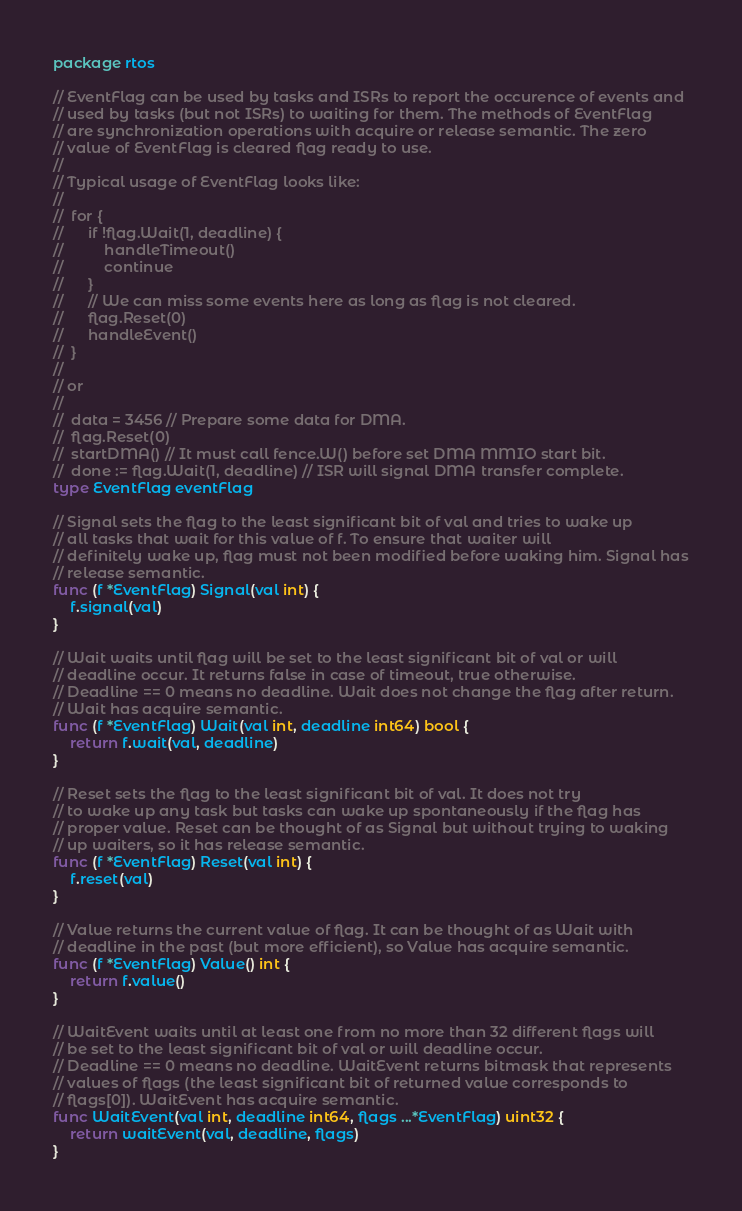<code> <loc_0><loc_0><loc_500><loc_500><_Go_>package rtos

// EventFlag can be used by tasks and ISRs to report the occurence of events and
// used by tasks (but not ISRs) to waiting for them. The methods of EventFlag
// are synchronization operations with acquire or release semantic. The zero
// value of EventFlag is cleared flag ready to use.
//
// Typical usage of EventFlag looks like:
//
//	for {
//		if !flag.Wait(1, deadline) {
//			handleTimeout()
//			continue
//		}
//		// We can miss some events here as long as flag is not cleared.
//		flag.Reset(0)
//		handleEvent()
//	}
//
// or
//
//	data = 3456 // Prepare some data for DMA.
//	flag.Reset(0)
//	startDMA() // It must call fence.W() before set DMA MMIO start bit.
//	done := flag.Wait(1, deadline) // ISR will signal DMA transfer complete.
type EventFlag eventFlag

// Signal sets the flag to the least significant bit of val and tries to wake up
// all tasks that wait for this value of f. To ensure that waiter will
// definitely wake up, flag must not been modified before waking him. Signal has
// release semantic.
func (f *EventFlag) Signal(val int) {
	f.signal(val)
}

// Wait waits until flag will be set to the least significant bit of val or will
// deadline occur. It returns false in case of timeout, true otherwise.
// Deadline == 0 means no deadline. Wait does not change the flag after return.
// Wait has acquire semantic.
func (f *EventFlag) Wait(val int, deadline int64) bool {
	return f.wait(val, deadline)
}

// Reset sets the flag to the least significant bit of val. It does not try
// to wake up any task but tasks can wake up spontaneously if the flag has
// proper value. Reset can be thought of as Signal but without trying to waking
// up waiters, so it has release semantic.
func (f *EventFlag) Reset(val int) {
	f.reset(val)
}

// Value returns the current value of flag. It can be thought of as Wait with
// deadline in the past (but more efficient), so Value has acquire semantic.
func (f *EventFlag) Value() int {
	return f.value()
}

// WaitEvent waits until at least one from no more than 32 different flags will
// be set to the least significant bit of val or will deadline occur.
// Deadline == 0 means no deadline. WaitEvent returns bitmask that represents
// values of flags (the least significant bit of returned value corresponds to
// flags[0]). WaitEvent has acquire semantic.
func WaitEvent(val int, deadline int64, flags ...*EventFlag) uint32 {
	return waitEvent(val, deadline, flags)
}
</code> 